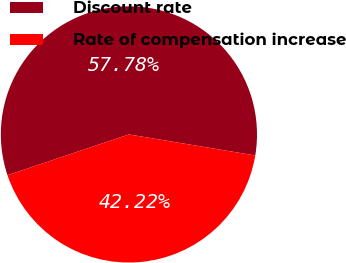Convert chart to OTSL. <chart><loc_0><loc_0><loc_500><loc_500><pie_chart><fcel>Discount rate<fcel>Rate of compensation increase<nl><fcel>57.78%<fcel>42.22%<nl></chart> 